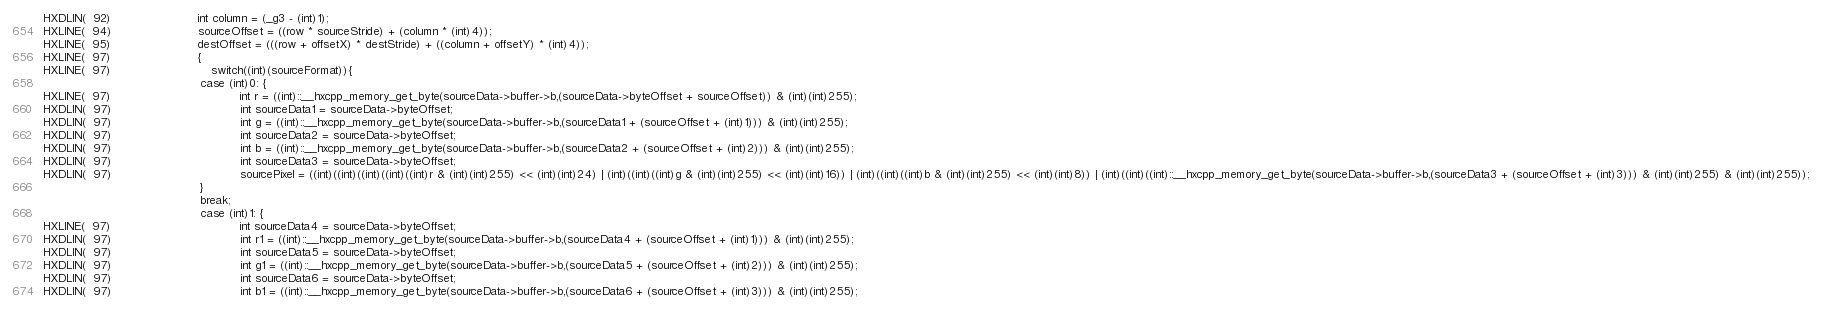Convert code to text. <code><loc_0><loc_0><loc_500><loc_500><_C++_>HXDLIN(  92)						int column = (_g3 - (int)1);
HXLINE(  94)						sourceOffset = ((row * sourceStride) + (column * (int)4));
HXLINE(  95)						destOffset = (((row + offsetX) * destStride) + ((column + offsetY) * (int)4));
HXLINE(  97)						{
HXLINE(  97)							switch((int)(sourceFormat)){
            								case (int)0: {
HXLINE(  97)									int r = ((int)::__hxcpp_memory_get_byte(sourceData->buffer->b,(sourceData->byteOffset + sourceOffset)) & (int)(int)255);
HXDLIN(  97)									int sourceData1 = sourceData->byteOffset;
HXDLIN(  97)									int g = ((int)::__hxcpp_memory_get_byte(sourceData->buffer->b,(sourceData1 + (sourceOffset + (int)1))) & (int)(int)255);
HXDLIN(  97)									int sourceData2 = sourceData->byteOffset;
HXDLIN(  97)									int b = ((int)::__hxcpp_memory_get_byte(sourceData->buffer->b,(sourceData2 + (sourceOffset + (int)2))) & (int)(int)255);
HXDLIN(  97)									int sourceData3 = sourceData->byteOffset;
HXDLIN(  97)									sourcePixel = ((int)((int)((int)((int)((int)r & (int)(int)255) << (int)(int)24) | (int)((int)((int)g & (int)(int)255) << (int)(int)16)) | (int)((int)((int)b & (int)(int)255) << (int)(int)8)) | (int)((int)((int)::__hxcpp_memory_get_byte(sourceData->buffer->b,(sourceData3 + (sourceOffset + (int)3))) & (int)(int)255) & (int)(int)255));
            								}
            								break;
            								case (int)1: {
HXLINE(  97)									int sourceData4 = sourceData->byteOffset;
HXDLIN(  97)									int r1 = ((int)::__hxcpp_memory_get_byte(sourceData->buffer->b,(sourceData4 + (sourceOffset + (int)1))) & (int)(int)255);
HXDLIN(  97)									int sourceData5 = sourceData->byteOffset;
HXDLIN(  97)									int g1 = ((int)::__hxcpp_memory_get_byte(sourceData->buffer->b,(sourceData5 + (sourceOffset + (int)2))) & (int)(int)255);
HXDLIN(  97)									int sourceData6 = sourceData->byteOffset;
HXDLIN(  97)									int b1 = ((int)::__hxcpp_memory_get_byte(sourceData->buffer->b,(sourceData6 + (sourceOffset + (int)3))) & (int)(int)255);</code> 